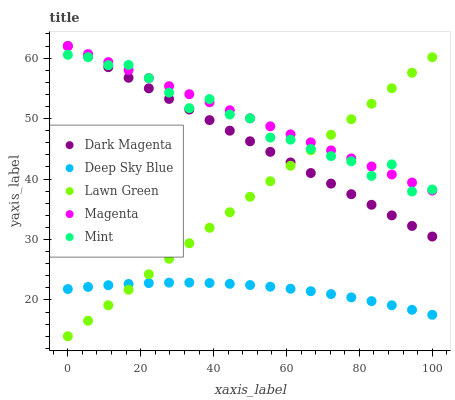Does Deep Sky Blue have the minimum area under the curve?
Answer yes or no. Yes. Does Magenta have the maximum area under the curve?
Answer yes or no. Yes. Does Mint have the minimum area under the curve?
Answer yes or no. No. Does Mint have the maximum area under the curve?
Answer yes or no. No. Is Lawn Green the smoothest?
Answer yes or no. Yes. Is Mint the roughest?
Answer yes or no. Yes. Is Magenta the smoothest?
Answer yes or no. No. Is Magenta the roughest?
Answer yes or no. No. Does Lawn Green have the lowest value?
Answer yes or no. Yes. Does Mint have the lowest value?
Answer yes or no. No. Does Dark Magenta have the highest value?
Answer yes or no. Yes. Does Mint have the highest value?
Answer yes or no. No. Is Deep Sky Blue less than Mint?
Answer yes or no. Yes. Is Dark Magenta greater than Deep Sky Blue?
Answer yes or no. Yes. Does Mint intersect Dark Magenta?
Answer yes or no. Yes. Is Mint less than Dark Magenta?
Answer yes or no. No. Is Mint greater than Dark Magenta?
Answer yes or no. No. Does Deep Sky Blue intersect Mint?
Answer yes or no. No. 